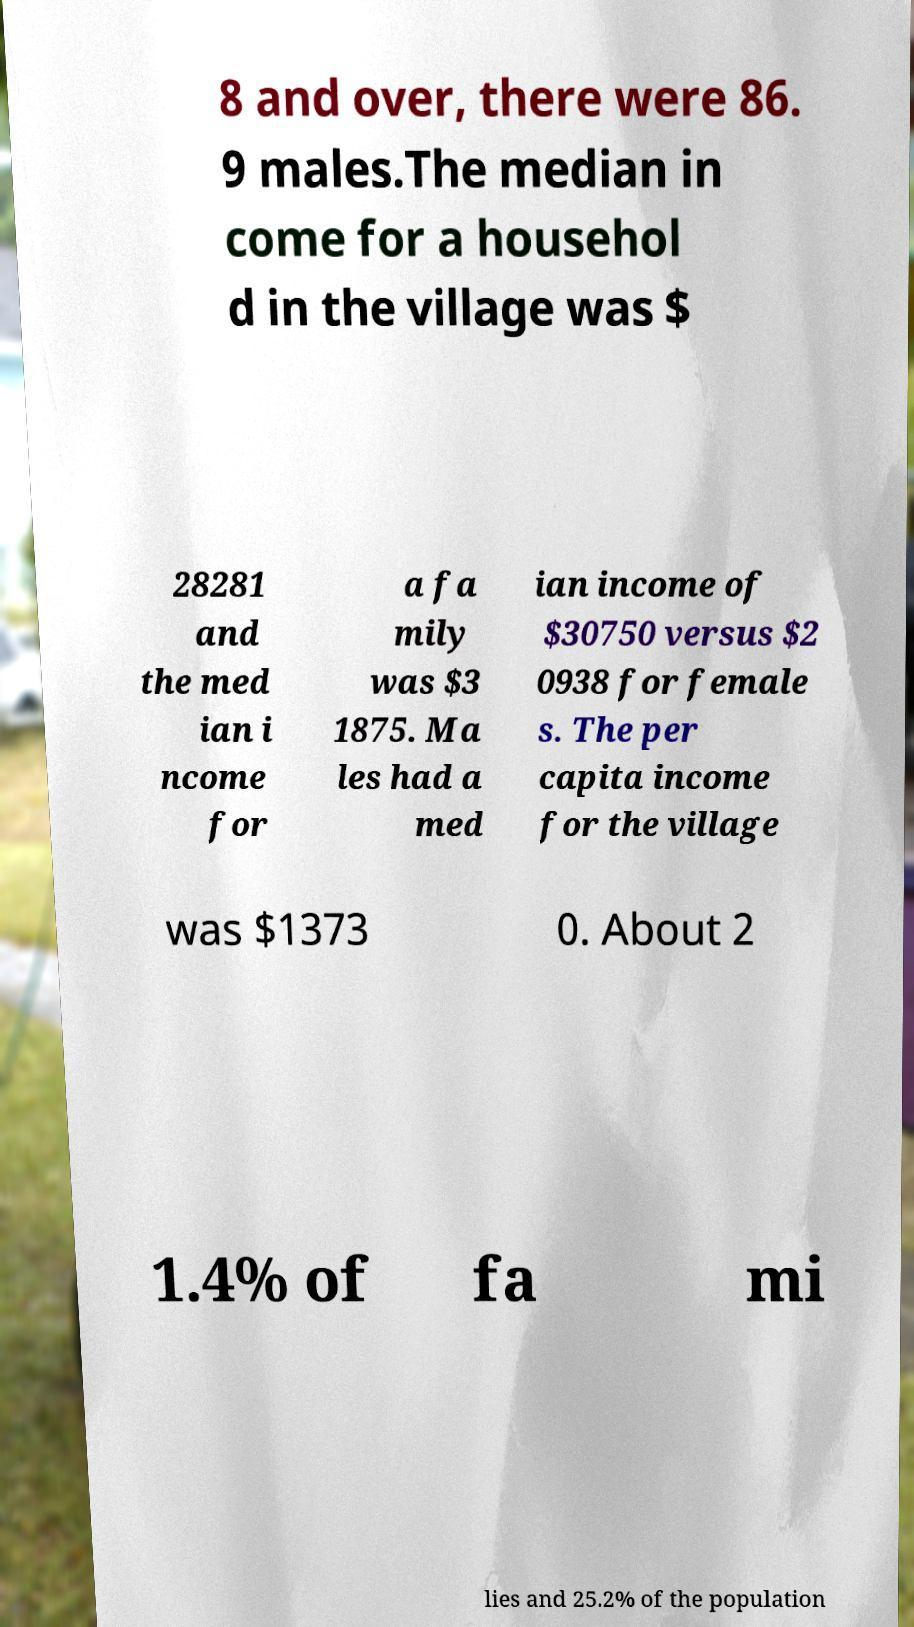Can you read and provide the text displayed in the image?This photo seems to have some interesting text. Can you extract and type it out for me? 8 and over, there were 86. 9 males.The median in come for a househol d in the village was $ 28281 and the med ian i ncome for a fa mily was $3 1875. Ma les had a med ian income of $30750 versus $2 0938 for female s. The per capita income for the village was $1373 0. About 2 1.4% of fa mi lies and 25.2% of the population 